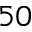<formula> <loc_0><loc_0><loc_500><loc_500>5 0</formula> 